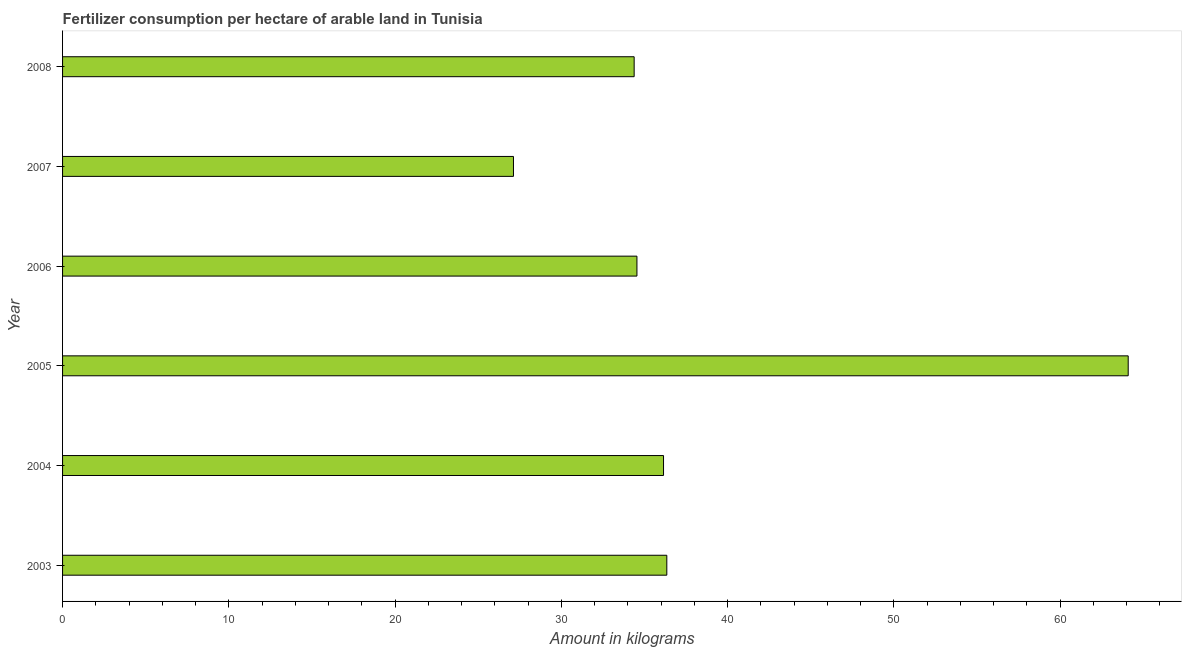Does the graph contain any zero values?
Give a very brief answer. No. What is the title of the graph?
Give a very brief answer. Fertilizer consumption per hectare of arable land in Tunisia . What is the label or title of the X-axis?
Ensure brevity in your answer.  Amount in kilograms. What is the label or title of the Y-axis?
Ensure brevity in your answer.  Year. What is the amount of fertilizer consumption in 2008?
Give a very brief answer. 34.38. Across all years, what is the maximum amount of fertilizer consumption?
Offer a terse response. 64.09. Across all years, what is the minimum amount of fertilizer consumption?
Provide a short and direct response. 27.12. In which year was the amount of fertilizer consumption maximum?
Your answer should be compact. 2005. What is the sum of the amount of fertilizer consumption?
Your response must be concise. 232.61. What is the difference between the amount of fertilizer consumption in 2003 and 2005?
Your answer should be compact. -27.75. What is the average amount of fertilizer consumption per year?
Give a very brief answer. 38.77. What is the median amount of fertilizer consumption?
Your response must be concise. 35.34. What is the ratio of the amount of fertilizer consumption in 2005 to that in 2007?
Your answer should be compact. 2.36. Is the amount of fertilizer consumption in 2003 less than that in 2007?
Ensure brevity in your answer.  No. What is the difference between the highest and the second highest amount of fertilizer consumption?
Make the answer very short. 27.75. Is the sum of the amount of fertilizer consumption in 2004 and 2005 greater than the maximum amount of fertilizer consumption across all years?
Provide a succinct answer. Yes. What is the difference between the highest and the lowest amount of fertilizer consumption?
Your answer should be very brief. 36.97. In how many years, is the amount of fertilizer consumption greater than the average amount of fertilizer consumption taken over all years?
Provide a short and direct response. 1. Are all the bars in the graph horizontal?
Provide a succinct answer. Yes. How many years are there in the graph?
Give a very brief answer. 6. What is the difference between two consecutive major ticks on the X-axis?
Give a very brief answer. 10. Are the values on the major ticks of X-axis written in scientific E-notation?
Provide a succinct answer. No. What is the Amount in kilograms in 2003?
Ensure brevity in your answer.  36.34. What is the Amount in kilograms in 2004?
Offer a very short reply. 36.14. What is the Amount in kilograms of 2005?
Keep it short and to the point. 64.09. What is the Amount in kilograms of 2006?
Offer a very short reply. 34.54. What is the Amount in kilograms of 2007?
Offer a very short reply. 27.12. What is the Amount in kilograms of 2008?
Provide a short and direct response. 34.38. What is the difference between the Amount in kilograms in 2003 and 2004?
Your answer should be very brief. 0.2. What is the difference between the Amount in kilograms in 2003 and 2005?
Your answer should be compact. -27.75. What is the difference between the Amount in kilograms in 2003 and 2006?
Your response must be concise. 1.8. What is the difference between the Amount in kilograms in 2003 and 2007?
Ensure brevity in your answer.  9.22. What is the difference between the Amount in kilograms in 2003 and 2008?
Ensure brevity in your answer.  1.96. What is the difference between the Amount in kilograms in 2004 and 2005?
Give a very brief answer. -27.95. What is the difference between the Amount in kilograms in 2004 and 2006?
Offer a terse response. 1.6. What is the difference between the Amount in kilograms in 2004 and 2007?
Provide a short and direct response. 9.03. What is the difference between the Amount in kilograms in 2004 and 2008?
Keep it short and to the point. 1.77. What is the difference between the Amount in kilograms in 2005 and 2006?
Make the answer very short. 29.55. What is the difference between the Amount in kilograms in 2005 and 2007?
Ensure brevity in your answer.  36.97. What is the difference between the Amount in kilograms in 2005 and 2008?
Your response must be concise. 29.71. What is the difference between the Amount in kilograms in 2006 and 2007?
Keep it short and to the point. 7.43. What is the difference between the Amount in kilograms in 2006 and 2008?
Give a very brief answer. 0.17. What is the difference between the Amount in kilograms in 2007 and 2008?
Make the answer very short. -7.26. What is the ratio of the Amount in kilograms in 2003 to that in 2004?
Ensure brevity in your answer.  1. What is the ratio of the Amount in kilograms in 2003 to that in 2005?
Offer a terse response. 0.57. What is the ratio of the Amount in kilograms in 2003 to that in 2006?
Your answer should be compact. 1.05. What is the ratio of the Amount in kilograms in 2003 to that in 2007?
Provide a short and direct response. 1.34. What is the ratio of the Amount in kilograms in 2003 to that in 2008?
Provide a succinct answer. 1.06. What is the ratio of the Amount in kilograms in 2004 to that in 2005?
Make the answer very short. 0.56. What is the ratio of the Amount in kilograms in 2004 to that in 2006?
Offer a very short reply. 1.05. What is the ratio of the Amount in kilograms in 2004 to that in 2007?
Your response must be concise. 1.33. What is the ratio of the Amount in kilograms in 2004 to that in 2008?
Your response must be concise. 1.05. What is the ratio of the Amount in kilograms in 2005 to that in 2006?
Provide a short and direct response. 1.85. What is the ratio of the Amount in kilograms in 2005 to that in 2007?
Your answer should be very brief. 2.36. What is the ratio of the Amount in kilograms in 2005 to that in 2008?
Keep it short and to the point. 1.86. What is the ratio of the Amount in kilograms in 2006 to that in 2007?
Offer a very short reply. 1.27. What is the ratio of the Amount in kilograms in 2007 to that in 2008?
Keep it short and to the point. 0.79. 